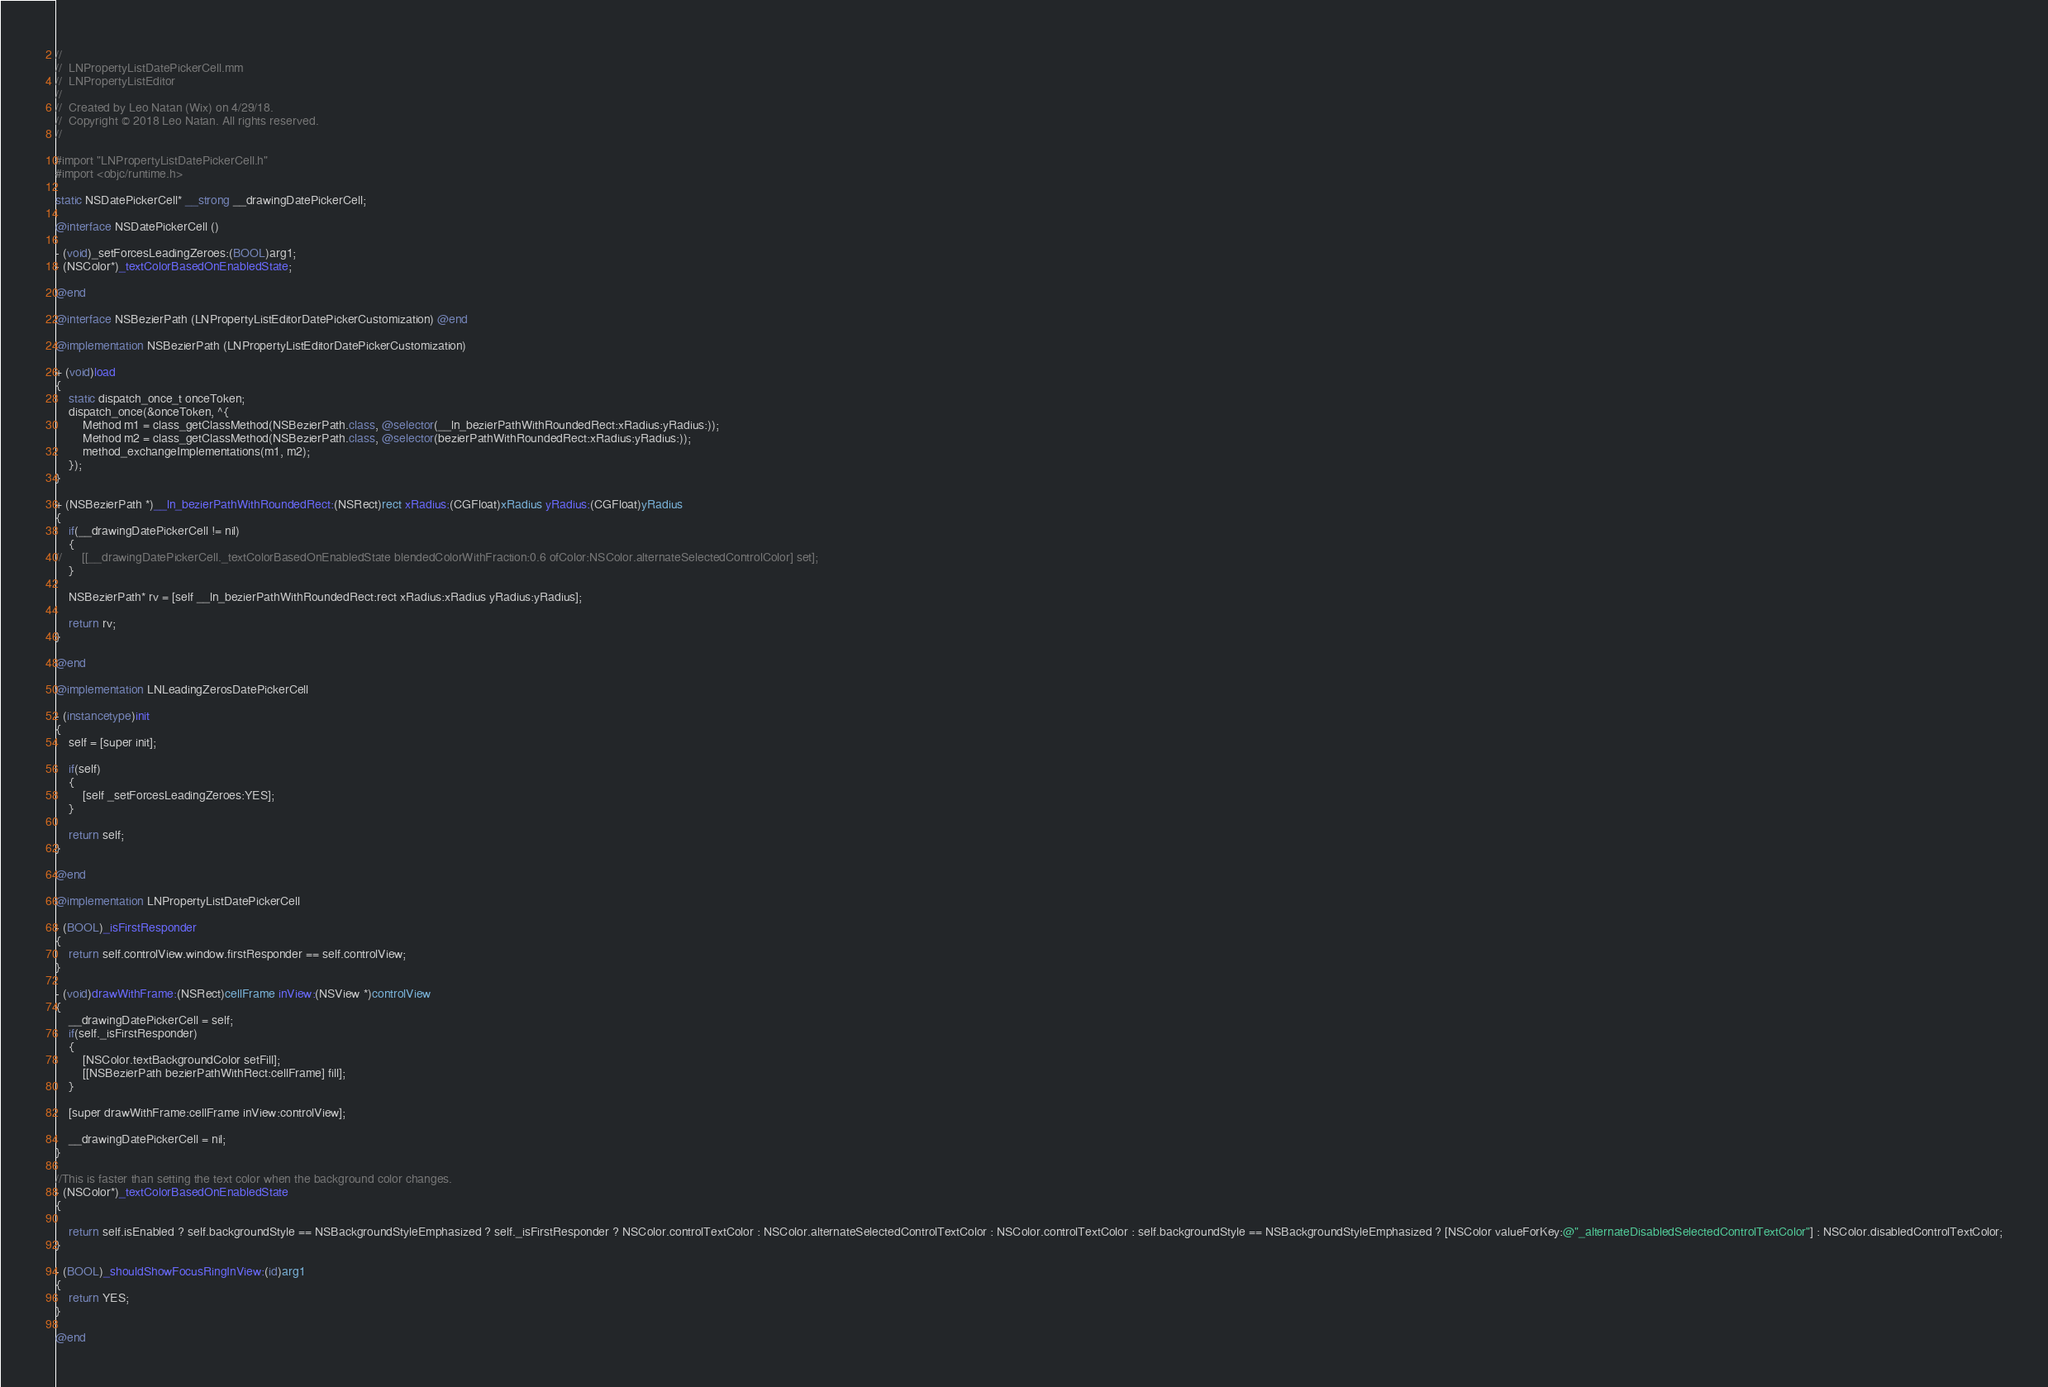Convert code to text. <code><loc_0><loc_0><loc_500><loc_500><_ObjectiveC_>//
//  LNPropertyListDatePickerCell.mm
//  LNPropertyListEditor
//
//  Created by Leo Natan (Wix) on 4/29/18.
//  Copyright © 2018 Leo Natan. All rights reserved.
//

#import "LNPropertyListDatePickerCell.h"
#import <objc/runtime.h>

static NSDatePickerCell* __strong __drawingDatePickerCell;

@interface NSDatePickerCell ()

- (void)_setForcesLeadingZeroes:(BOOL)arg1;
- (NSColor*)_textColorBasedOnEnabledState;

@end

@interface NSBezierPath (LNPropertyListEditorDatePickerCustomization) @end

@implementation NSBezierPath (LNPropertyListEditorDatePickerCustomization)

+ (void)load
{
	static dispatch_once_t onceToken;
	dispatch_once(&onceToken, ^{
		Method m1 = class_getClassMethod(NSBezierPath.class, @selector(__ln_bezierPathWithRoundedRect:xRadius:yRadius:));
		Method m2 = class_getClassMethod(NSBezierPath.class, @selector(bezierPathWithRoundedRect:xRadius:yRadius:));
		method_exchangeImplementations(m1, m2);
	});
}

+ (NSBezierPath *)__ln_bezierPathWithRoundedRect:(NSRect)rect xRadius:(CGFloat)xRadius yRadius:(CGFloat)yRadius
{
	if(__drawingDatePickerCell != nil)
	{
//		[[__drawingDatePickerCell._textColorBasedOnEnabledState blendedColorWithFraction:0.6 ofColor:NSColor.alternateSelectedControlColor] set];
	}
	
	NSBezierPath* rv = [self __ln_bezierPathWithRoundedRect:rect xRadius:xRadius yRadius:yRadius];
	
	return rv;
}

@end

@implementation LNLeadingZerosDatePickerCell

- (instancetype)init
{
	self = [super init];
	
	if(self)
	{
		[self _setForcesLeadingZeroes:YES];
	}
	
	return self;
}

@end

@implementation LNPropertyListDatePickerCell

- (BOOL)_isFirstResponder
{
	return self.controlView.window.firstResponder == self.controlView;
}

- (void)drawWithFrame:(NSRect)cellFrame inView:(NSView *)controlView
{
	__drawingDatePickerCell = self;
	if(self._isFirstResponder)
	{
		[NSColor.textBackgroundColor setFill];
		[[NSBezierPath bezierPathWithRect:cellFrame] fill];
	}
	
	[super drawWithFrame:cellFrame inView:controlView];
	
	__drawingDatePickerCell = nil;
}

//This is faster than setting the text color when the background color changes.
- (NSColor*)_textColorBasedOnEnabledState
{
	
	return self.isEnabled ? self.backgroundStyle == NSBackgroundStyleEmphasized ? self._isFirstResponder ? NSColor.controlTextColor : NSColor.alternateSelectedControlTextColor : NSColor.controlTextColor : self.backgroundStyle == NSBackgroundStyleEmphasized ? [NSColor valueForKey:@"_alternateDisabledSelectedControlTextColor"] : NSColor.disabledControlTextColor;
}

- (BOOL)_shouldShowFocusRingInView:(id)arg1
{
	return YES;
}

@end
</code> 